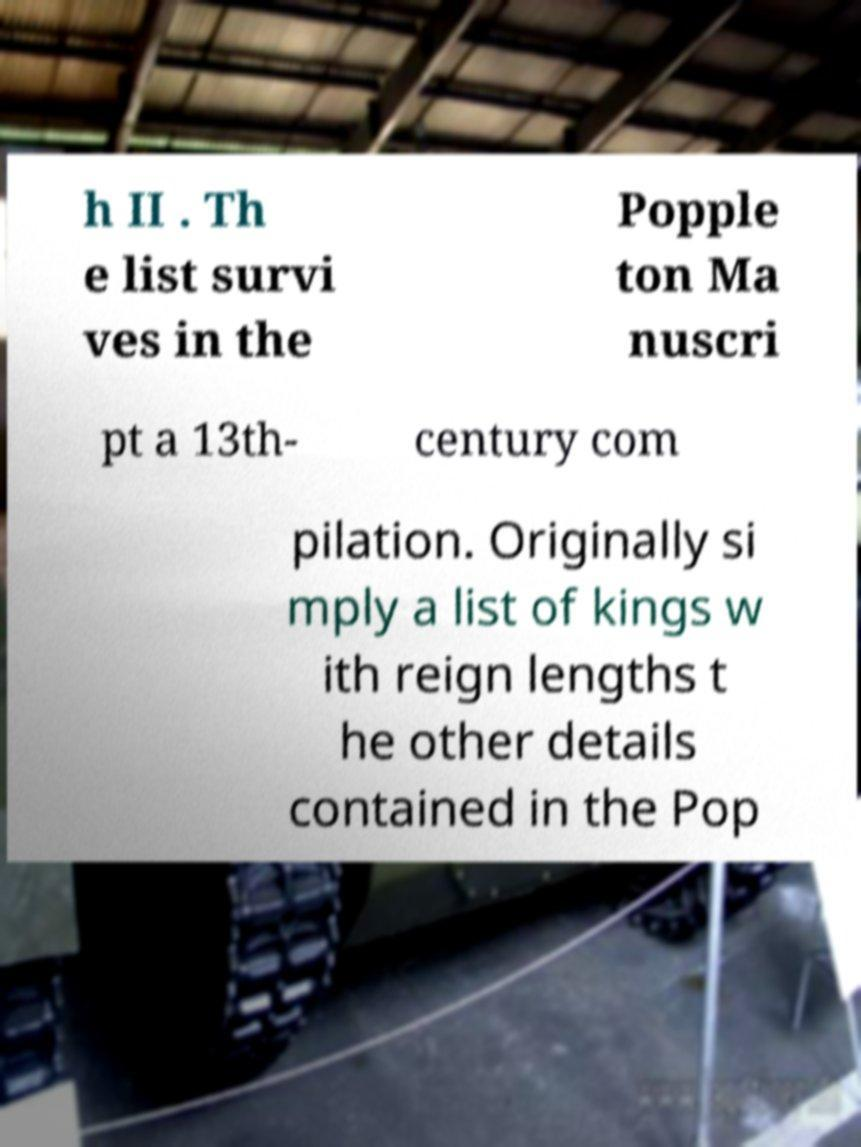I need the written content from this picture converted into text. Can you do that? h II . Th e list survi ves in the Popple ton Ma nuscri pt a 13th- century com pilation. Originally si mply a list of kings w ith reign lengths t he other details contained in the Pop 